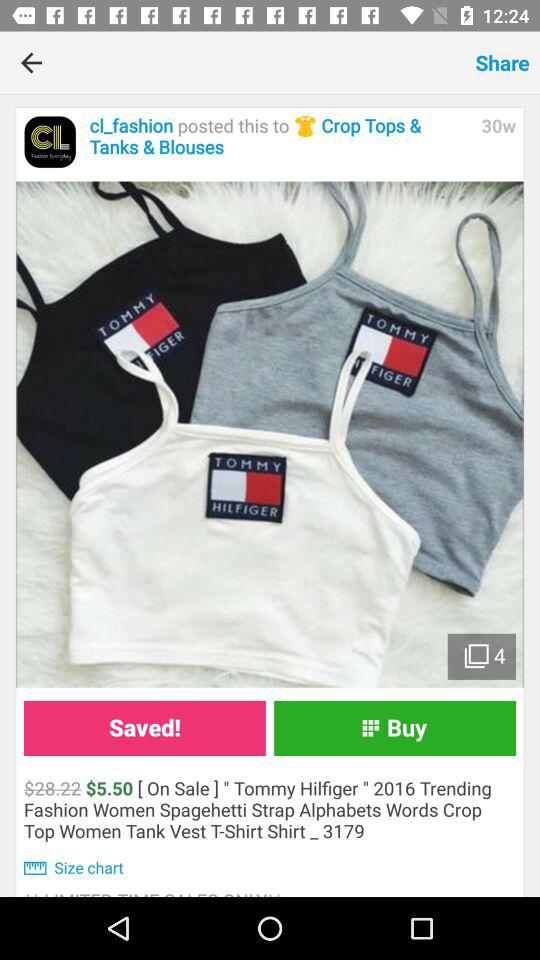What's the price of the product? The price of the product is $5.50. 